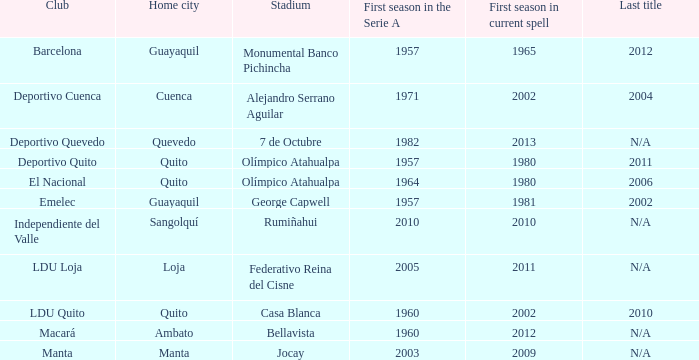State the final title given to cuenca. 2004.0. 